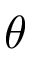Convert formula to latex. <formula><loc_0><loc_0><loc_500><loc_500>\theta</formula> 